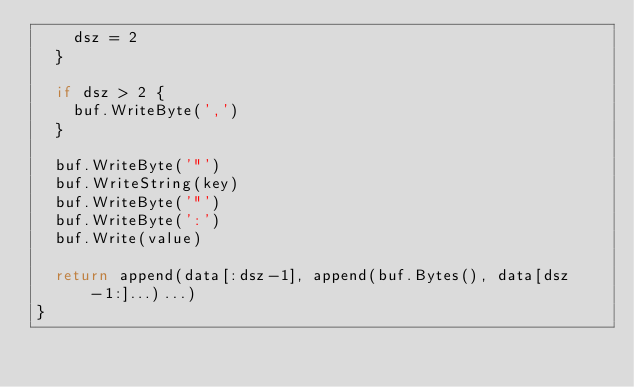Convert code to text. <code><loc_0><loc_0><loc_500><loc_500><_Go_>		dsz = 2
	}

	if dsz > 2 {
		buf.WriteByte(',')
	}

	buf.WriteByte('"')
	buf.WriteString(key)
	buf.WriteByte('"')
	buf.WriteByte(':')
	buf.Write(value)

	return append(data[:dsz-1], append(buf.Bytes(), data[dsz-1:]...)...)
}
</code> 